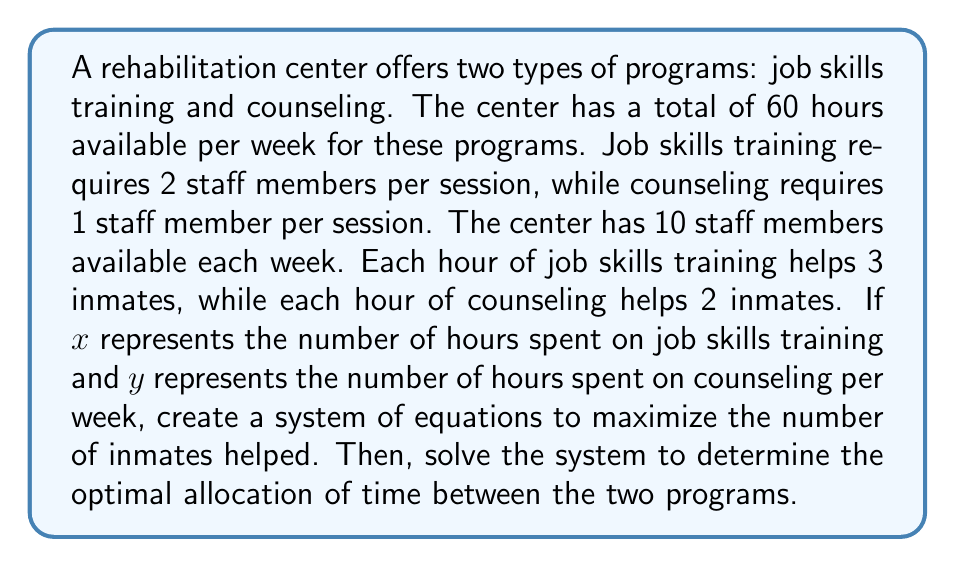Provide a solution to this math problem. Let's approach this step-by-step:

1) First, we need to set up our constraints:

   Time constraint: $x + y = 60$
   Staff constraint: $2x + y \leq 10 \cdot 60 = 600$

2) Our objective function (number of inmates helped) is:
   $f(x,y) = 3x + 2y$

3) We want to maximize this function subject to our constraints. In such cases, the maximum often occurs at the intersection of the constraint lines.

4) Let's solve the system of equations:
   $x + y = 60$
   $2x + y = 600$

5) Subtracting the first equation from the second:
   $x = 540$

6) Substituting this back into $x + y = 60$:
   $540 + y = 60$
   $y = -480$

7) However, $y$ cannot be negative as it represents time. This means our solution lies on the boundary of the time constraint.

8) Let's test the endpoints of our time constraint:
   When $x = 0$, $y = 60$: $f(0,60) = 0 + 2(60) = 120$ inmates helped
   When $x = 60$, $y = 0$: $f(60,0) = 3(60) + 0 = 180$ inmates helped

9) Therefore, the optimal solution is to spend all 60 hours on job skills training.
Answer: The optimal allocation is 60 hours for job skills training and 0 hours for counseling, helping a maximum of 180 inmates per week. 